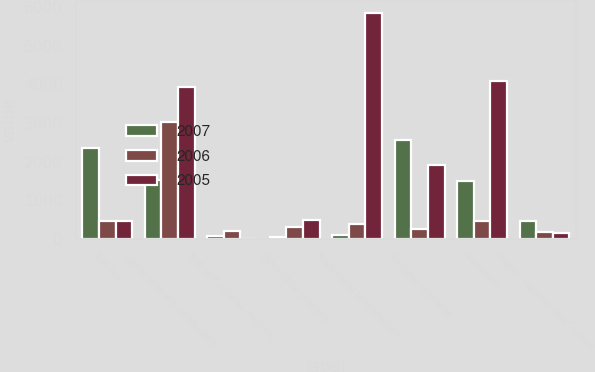Convert chart. <chart><loc_0><loc_0><loc_500><loc_500><stacked_bar_chart><ecel><fcel>Net loss<fcel>Depreciation and amortization<fcel>Bad debt expense (recovery)<fcel>Deferred tax provision<fcel>Stock-based compensation<fcel>Accounts receivable<fcel>Inventories<fcel>Prepaid expenses other current<nl><fcel>2007<fcel>2342<fcel>1529<fcel>67<fcel>36<fcel>98<fcel>2563<fcel>1491<fcel>465<nl><fcel>2006<fcel>465<fcel>3030<fcel>193<fcel>310<fcel>371<fcel>258<fcel>465<fcel>173<nl><fcel>2005<fcel>465<fcel>3915<fcel>7<fcel>475<fcel>5848<fcel>1920<fcel>4095<fcel>159<nl></chart> 